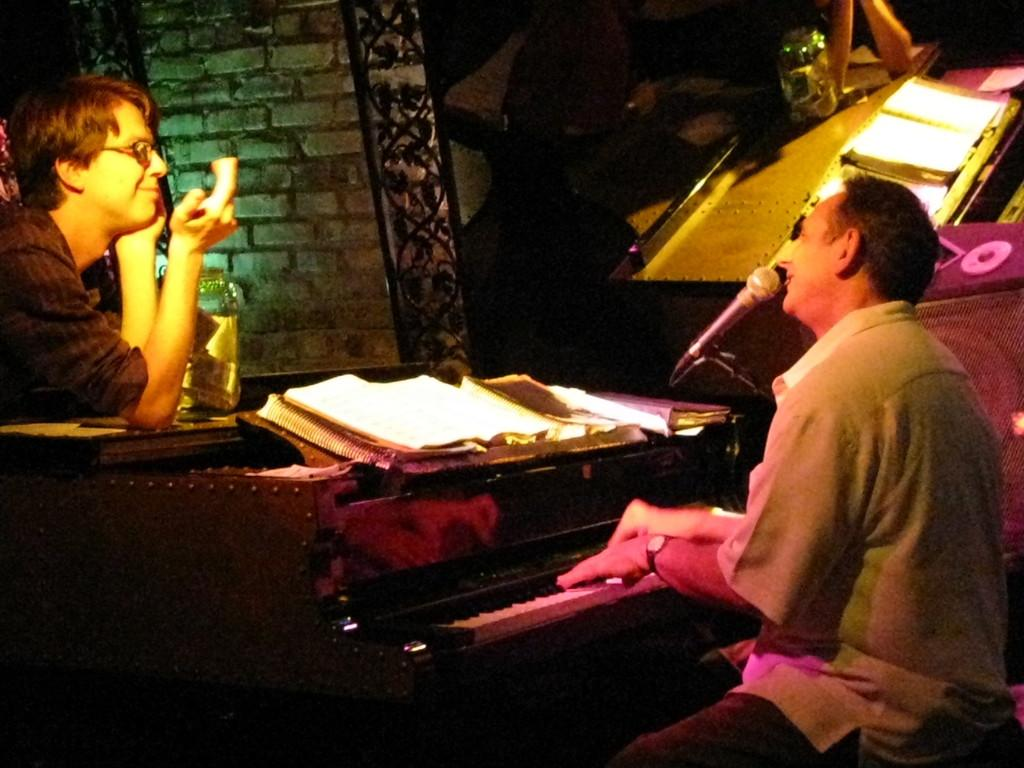What is the man in the image doing? The man is seated and playing the piano while singing. How is the man's voice being amplified? The man is using a microphone. Is there anyone else in the image? Yes, there is another man standing and looking at the person playing the piano. What else can be seen in the image? There are books visible in the image. What type of wall can be seen in the image? There is no wall present in the image. 